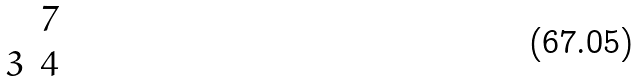Convert formula to latex. <formula><loc_0><loc_0><loc_500><loc_500>\begin{matrix} & 7 \\ 3 & 4 \end{matrix}</formula> 